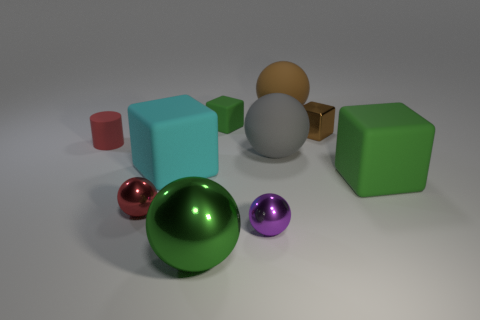Which object stands out the most to you, and why? The large green reflective sphere stands out the most due to its vibrant color and highly reflective surface that contrasts with the matte textures of some of the surrounding objects. Its size and central positioning also draw attention. 